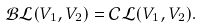Convert formula to latex. <formula><loc_0><loc_0><loc_500><loc_500>\mathcal { B L } ( V _ { 1 } , V _ { 2 } ) = \mathcal { C L } ( V _ { 1 } , V _ { 2 } ) .</formula> 